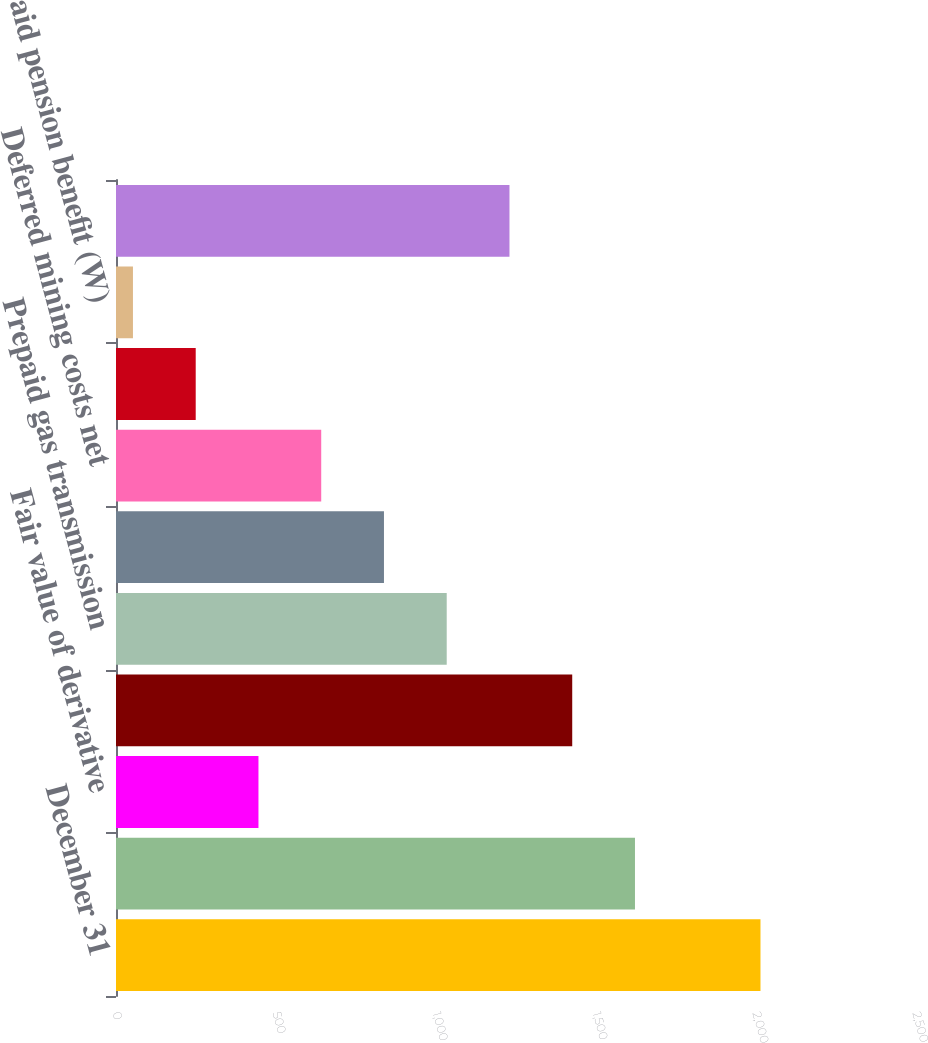Convert chart to OTSL. <chart><loc_0><loc_0><loc_500><loc_500><bar_chart><fcel>December 31<fcel>Intangibles net (E)<fcel>Fair value of derivative<fcel>Cash surrender value of life<fcel>Prepaid gas transmission<fcel>Value-added tax receivable<fcel>Deferred mining costs net<fcel>Unamortized debt expense<fcel>Prepaid pension benefit (W)<fcel>Other<nl><fcel>2014<fcel>1621.8<fcel>445.2<fcel>1425.7<fcel>1033.5<fcel>837.4<fcel>641.3<fcel>249.1<fcel>53<fcel>1229.6<nl></chart> 